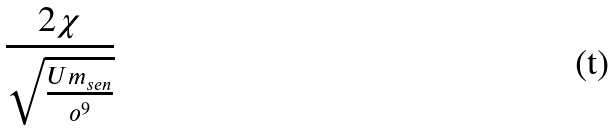Convert formula to latex. <formula><loc_0><loc_0><loc_500><loc_500>\frac { 2 \chi } { \sqrt { \frac { U m _ { s e n } } { o ^ { 9 } } } }</formula> 